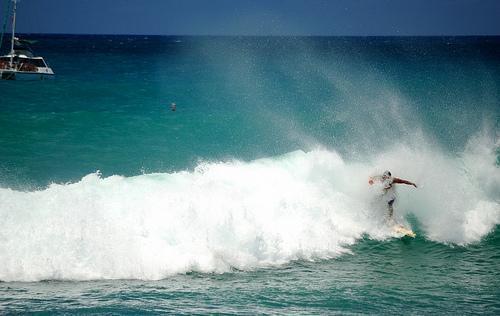How many boats can be seen?
Give a very brief answer. 1. How many surfers are in the water?
Give a very brief answer. 1. 